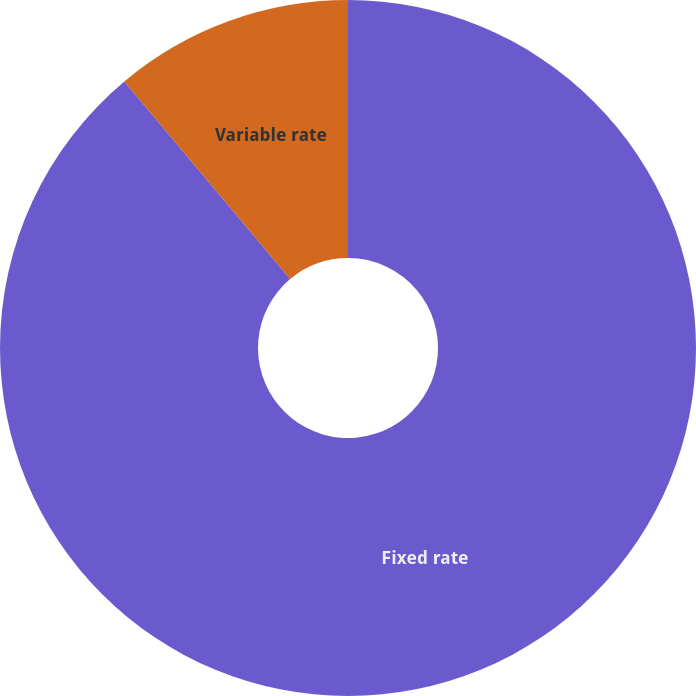<chart> <loc_0><loc_0><loc_500><loc_500><pie_chart><fcel>Fixed rate<fcel>Variable rate<nl><fcel>88.89%<fcel>11.11%<nl></chart> 